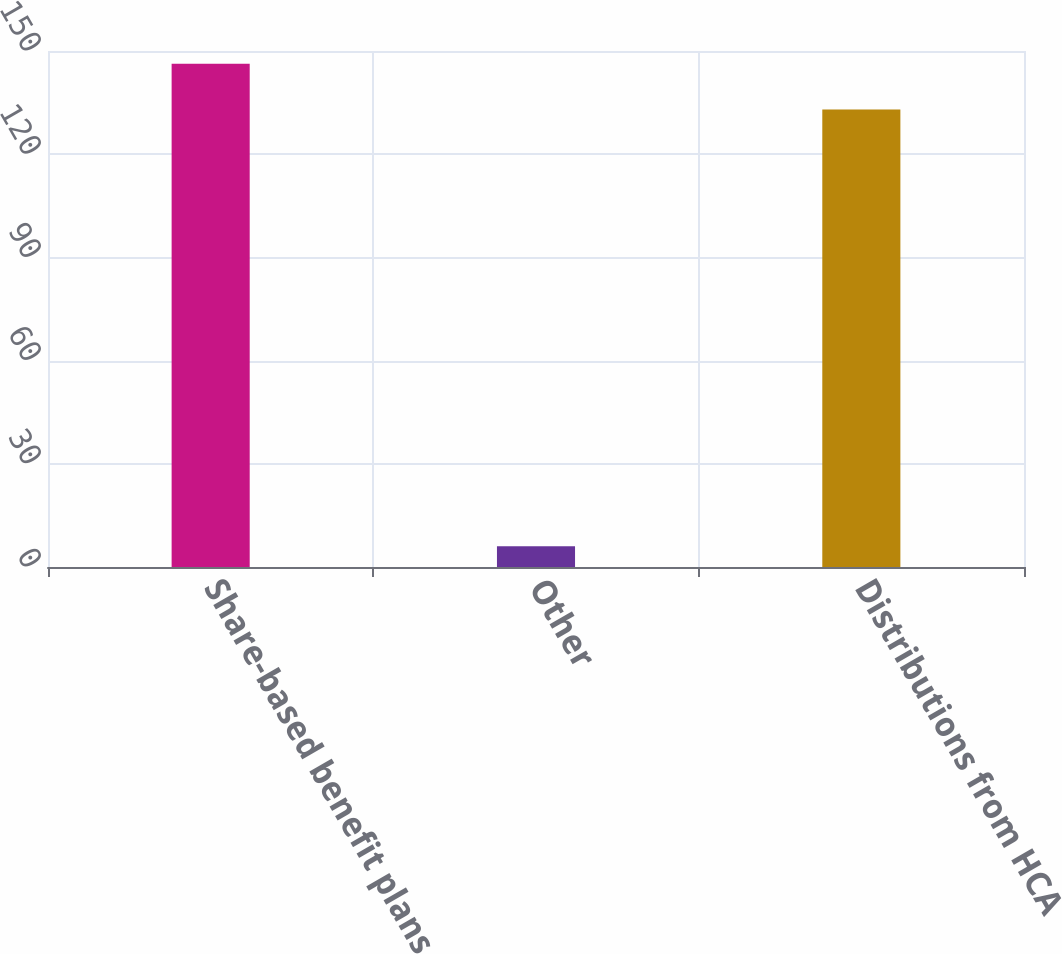Convert chart. <chart><loc_0><loc_0><loc_500><loc_500><bar_chart><fcel>Share-based benefit plans<fcel>Other<fcel>Distributions from HCA<nl><fcel>146.3<fcel>6<fcel>133<nl></chart> 